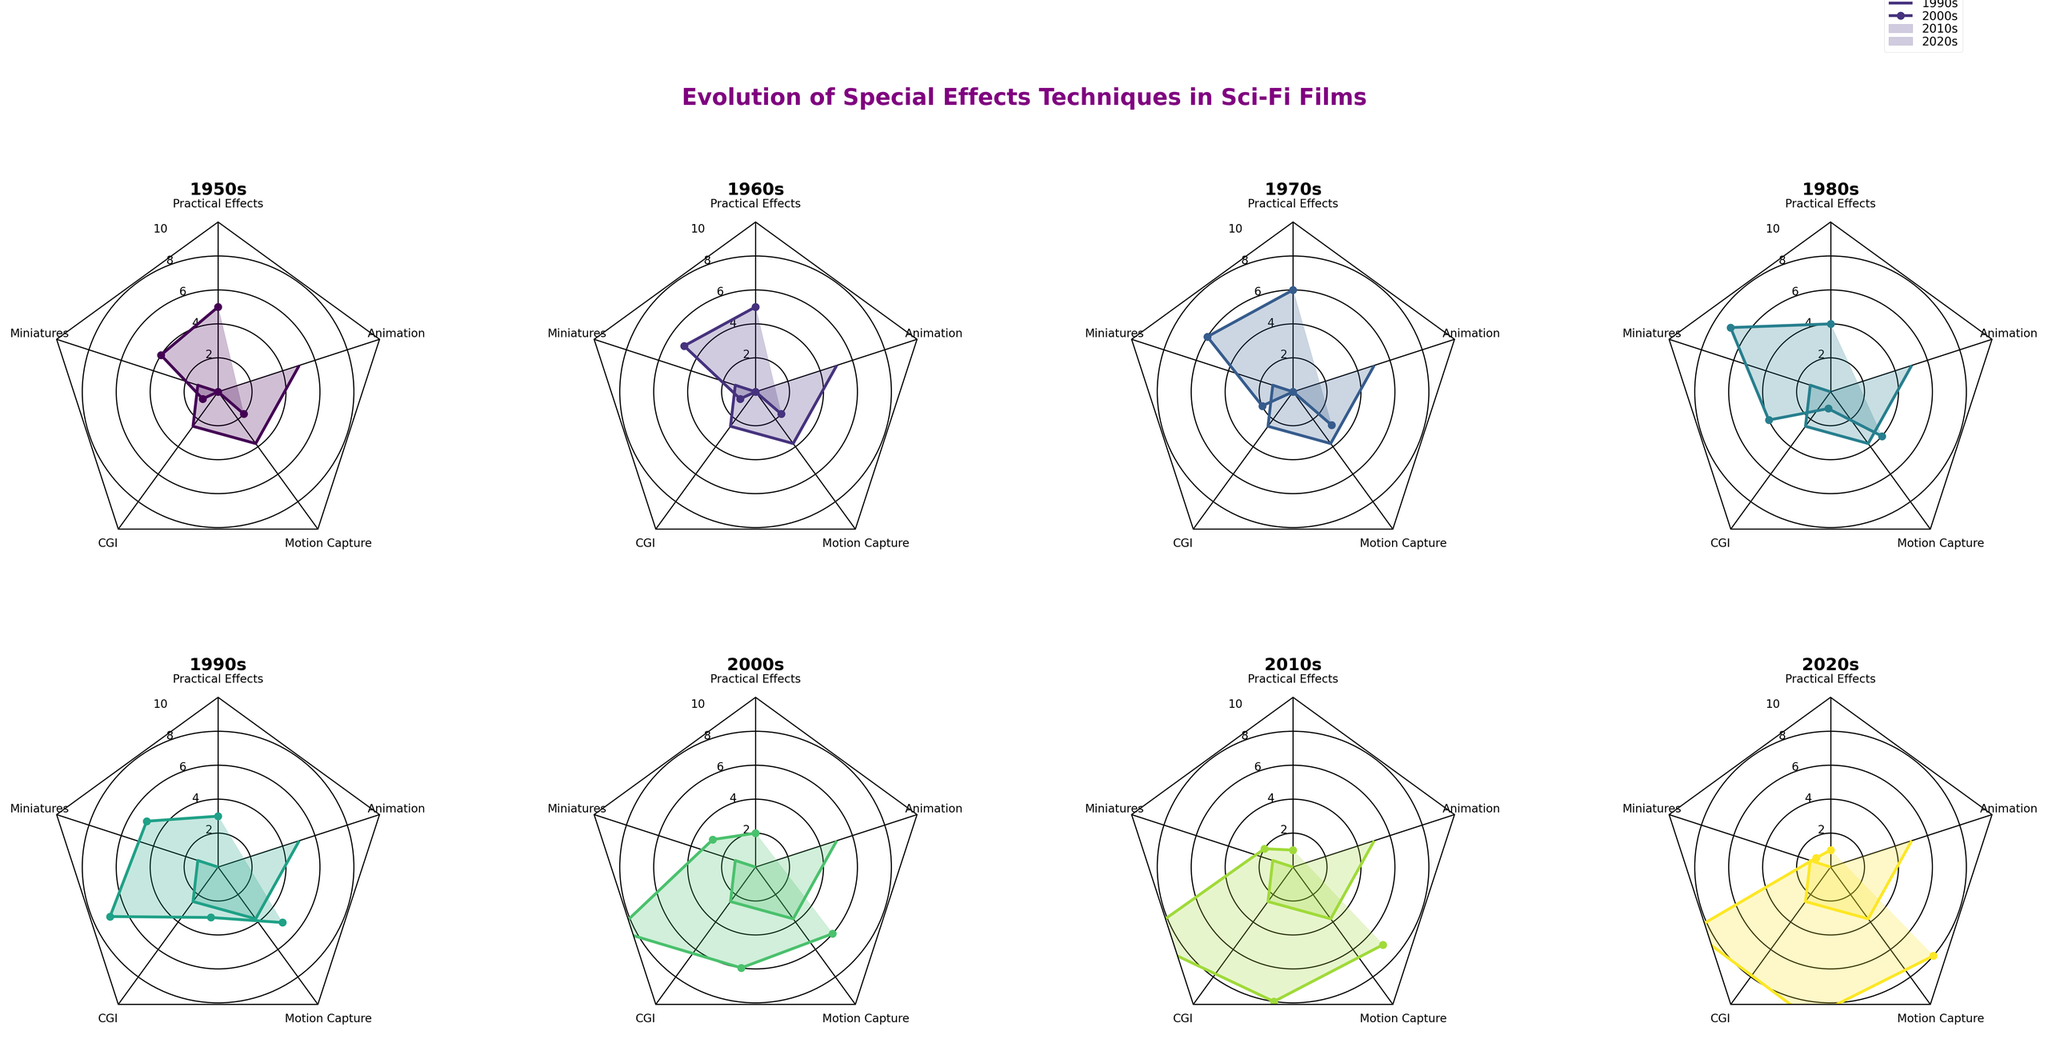What is the title of the figure? The title is usually located at the top of the figure and directly gives an overview of the chart's subject. You can read it to find out what the figure is about.
Answer: Evolution of Special Effects Techniques in Sci-Fi Films Which era has the highest use of Practical Effects? The era with the highest Practical Effects is identifiable by finding the radar chart segment labeled "Practical Effects" and noting which era's line reaches the highest point in that segment.
Answer: 1970s How many special effects techniques are represented in each radar chart? Count the number of axes radiating from the center of any radar chart; each represents a different special effect technique.
Answer: 5 Compare the use of CGI in the 1980s and 2020s. Which era used it more? Look at the radar chart sections labeled "CGI" for both the 1980s and 2020s and see which one extends further out from the center.
Answer: 2020s Which era shows the lowest combined use of Practical Effects and Miniatures? Identify the value for Practical Effects and Miniatures for each era, sum them, and find the era with the smallest sum.
Answer: 2020s In which era did Motion Capture first appear? Identify by looking for the first radar chart where the "Motion Capture" segment is not at zero.
Answer: 1980s What is the average Animation usage from the 1950s to the 2020s? Sum the values for Animation over all the eras and then divide by the number of eras (8). (2+2+3+4+5+6+7+8)/8 = 4.625
Answer: 4.625 What trend can be seen in the usage of CGI from the 1950s to the 2020s? Observe the radar charts for each era and note the values for CGI. Track the changes across the decades. CGI usage increases over time.
Answer: Increasing trend Which special effect technique has remained mostly consistent across the eras? Compare the segments of each radar chart and look for the segment with the least variation in radius across eras.
Answer: Miniatures How does the usage of Practical Effects in the 1950s compare to the 2010s? Compare the "Practical Effects" segments in the radar charts for the 1950s and the 2010s, noticing the difference.
Answer: 1950s higher 